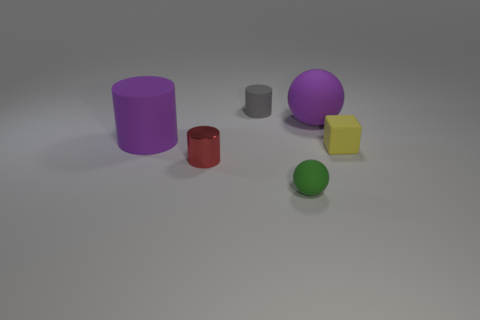If we consider the red cylinder as a reference, how are the other objects arranged in relation to it? Taking the red cylinder as a point of reference, the purple cylinder is placed towards the left and slightly behind it, the green sphere is directly behind, the grey cylinder is in front and to the left, the yellow cube is in front and to the right, and the violet sphere is off to the right and at the back. 